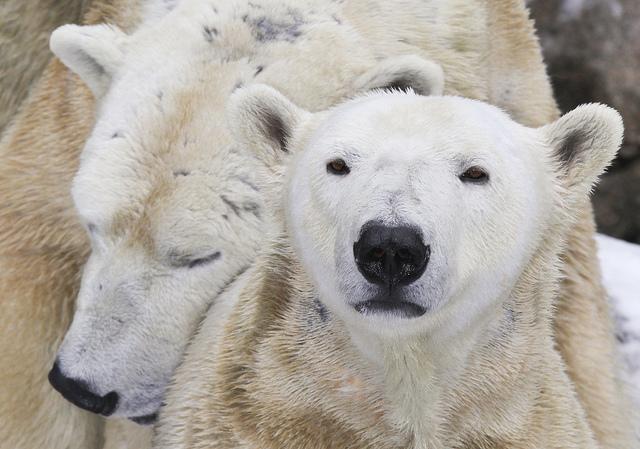How many bears are there?
Write a very short answer. 2. Are these teddy bears?
Write a very short answer. No. Are these natives of South America?
Be succinct. No. 